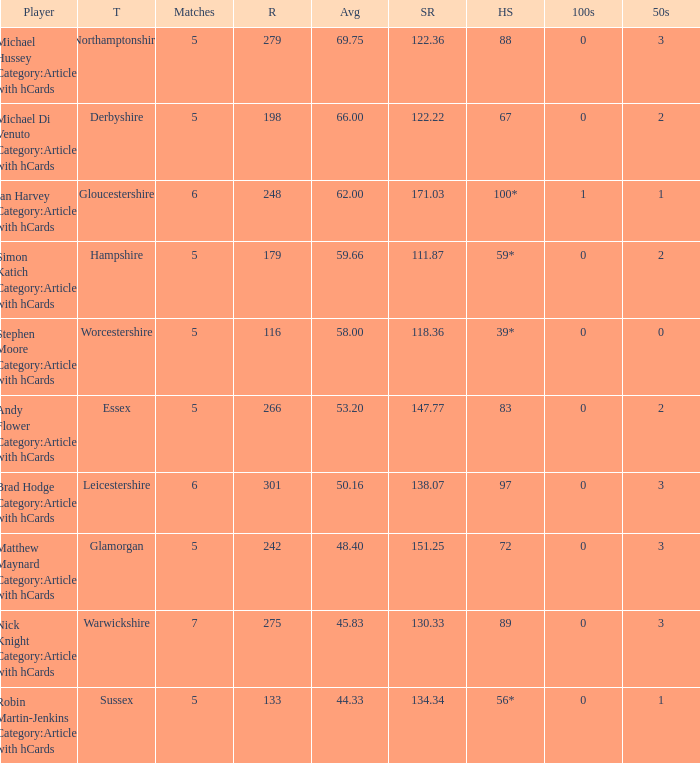If the team is Gloucestershire, what is the average? 62.0. 